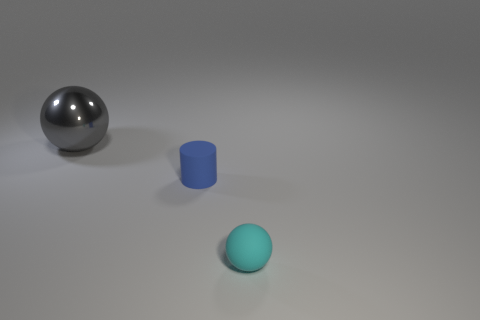Subtract all brown cylinders. Subtract all yellow cubes. How many cylinders are left? 1 Add 2 gray spheres. How many objects exist? 5 Subtract all cylinders. How many objects are left? 2 Add 1 big blue metallic cylinders. How many big blue metallic cylinders exist? 1 Subtract 1 gray spheres. How many objects are left? 2 Subtract all shiny spheres. Subtract all tiny things. How many objects are left? 0 Add 3 big gray spheres. How many big gray spheres are left? 4 